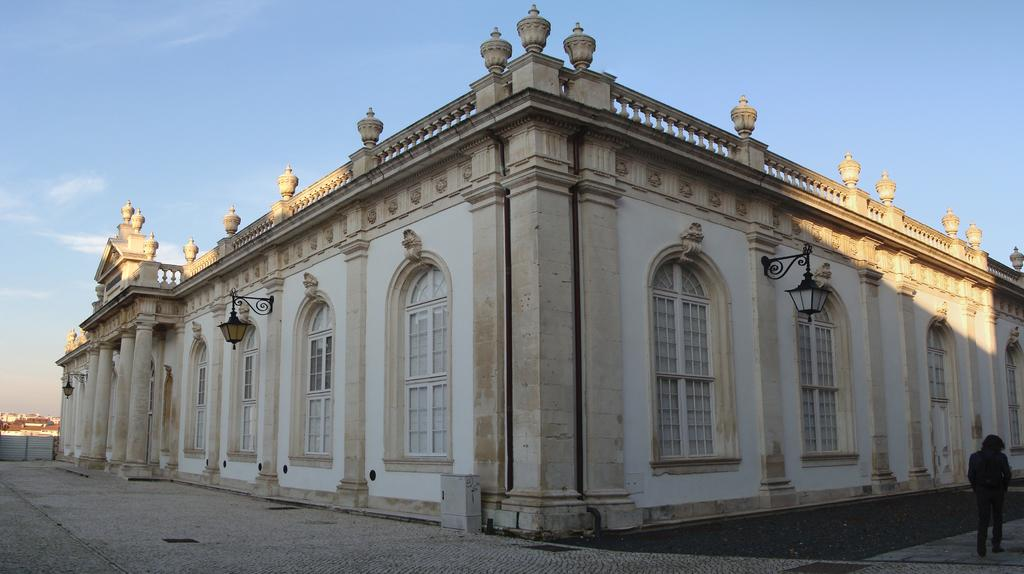What is the man in the image doing? The man is walking in the image. Where is the man walking? The man is walking on a path. What can be seen in the background of the image? There is a building, houses, and the sky visible in the background of the image. What is the source of illumination in the image? There are lights visible in the image. What type of industry can be seen in the image? There is no industry present in the image; it features a man walking on a path with a building, houses, and lights visible in the background. 